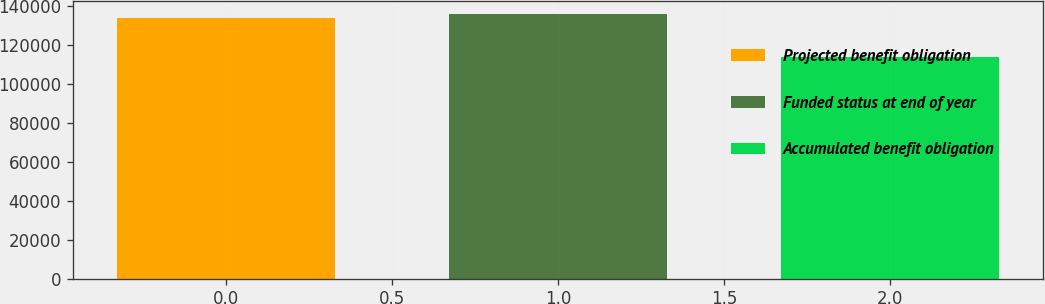Convert chart. <chart><loc_0><loc_0><loc_500><loc_500><bar_chart><fcel>Projected benefit obligation<fcel>Funded status at end of year<fcel>Accumulated benefit obligation<nl><fcel>133935<fcel>135957<fcel>113712<nl></chart> 